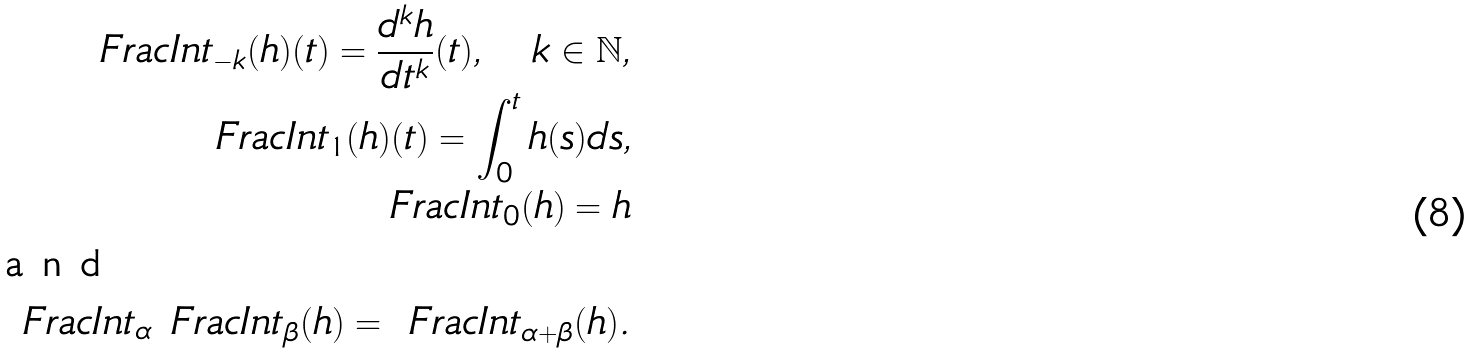Convert formula to latex. <formula><loc_0><loc_0><loc_500><loc_500>\ F r a c I n t _ { - k } ( h ) ( t ) = \frac { d ^ { k } h } { d t ^ { k } } ( t ) , \quad k \in { \mathbb { N } } , \\ \ F r a c I n t _ { 1 } ( h ) ( t ) = \int _ { 0 } ^ { t } h ( s ) d s , \\ \ F r a c I n t _ { 0 } ( h ) = h \\ \intertext { a n d } \ F r a c I n t _ { \alpha } \ F r a c I n t _ { \beta } ( h ) = \ F r a c I n t _ { \alpha + \beta } ( h ) .</formula> 